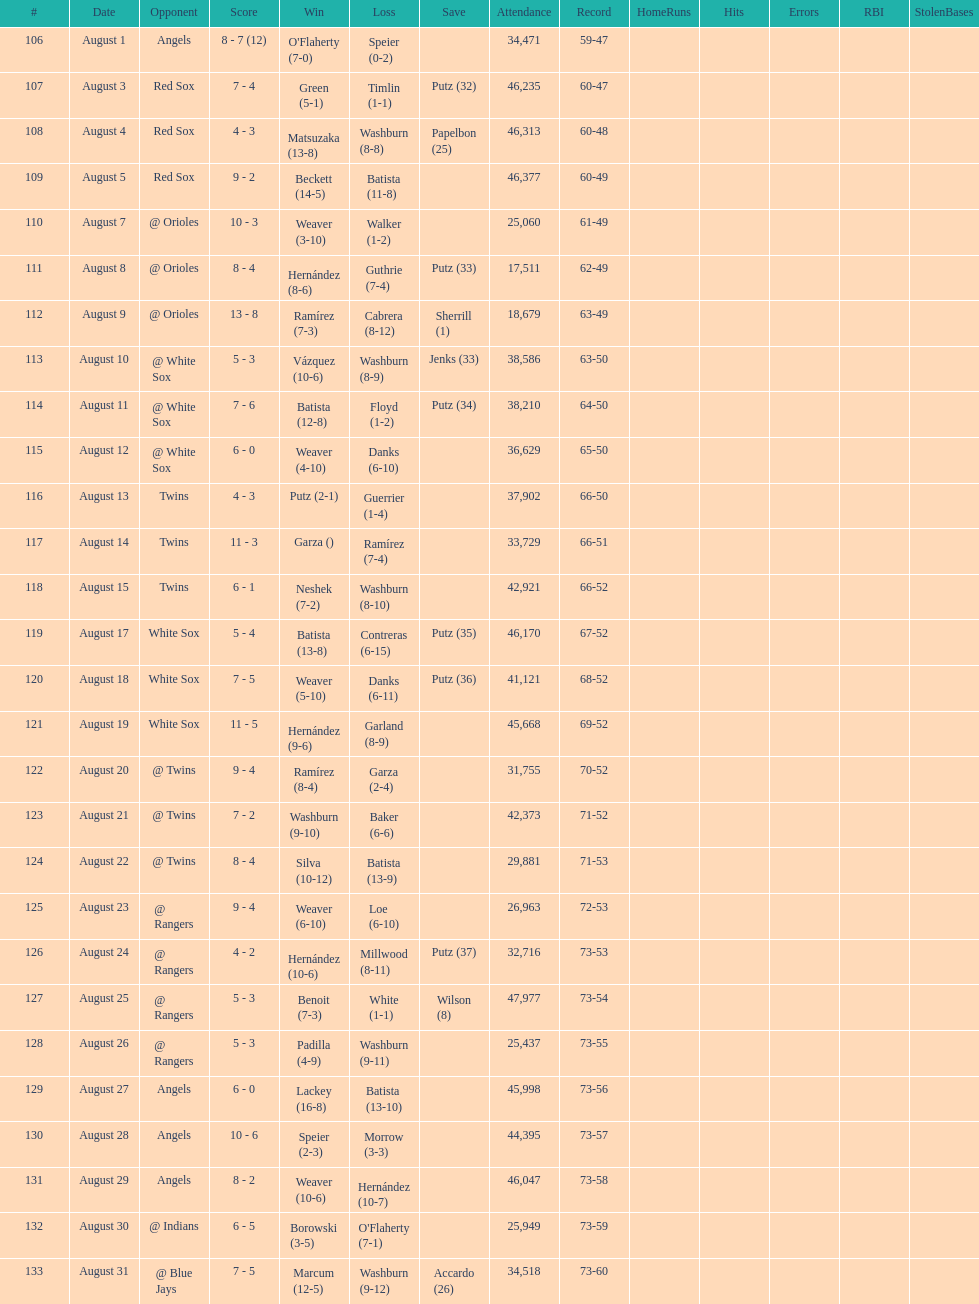How many losses during stretch? 7. 